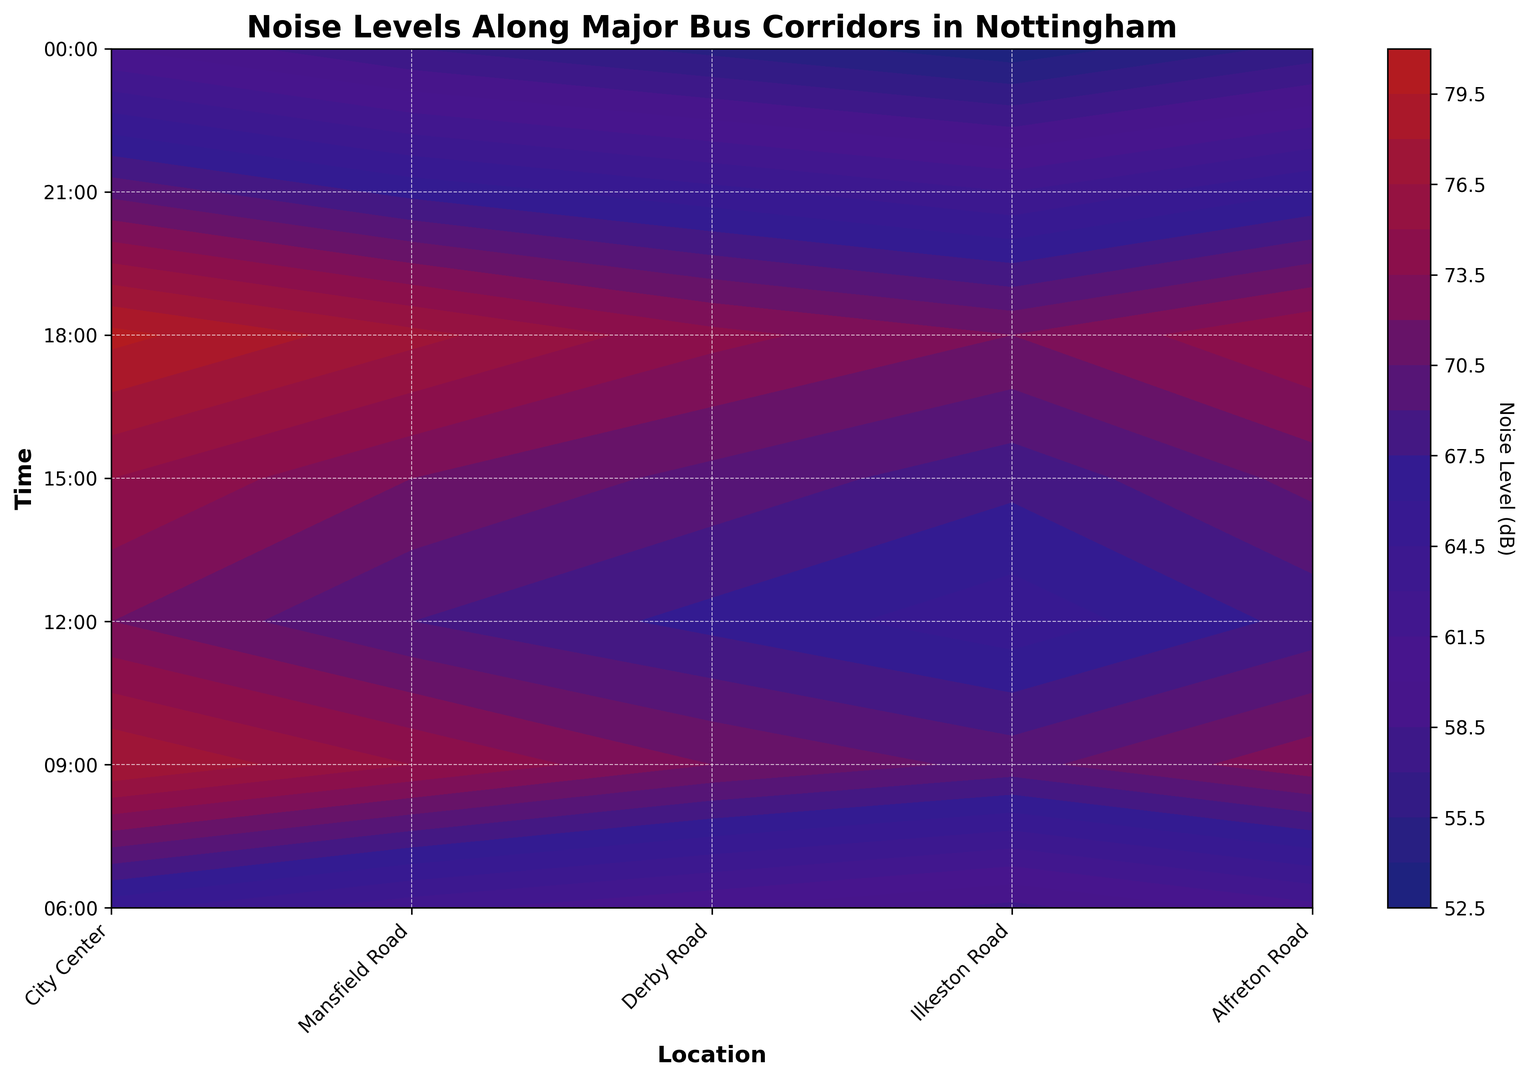Which location has the highest noise level at 18:00? To identify the location with the highest noise level at 18:00, inspect the row corresponding to 18:00. The column "City Center" shows the highest noise level of 80 dB.
Answer: City Center What is the noise level difference between the City Center and Derby Road at 09:00? Locate the noise levels at 09:00 for both locations: City Center is 78 dB and Derby Road is 72 dB. Subtract Derby Road's noise level from the City Center's noise level: 78 - 72 = 6 dB.
Answer: 6 dB Which time of day has the highest overall noise level for Mansfield Road? Scan the column for Mansfield Road and identify the highest value. The highest noise level is 77 dB at 18:00.
Answer: 18:00 On Ilkeston Road, when is the noise level the lowest? Find the row with the lowest noise level in the column for Ilkeston Road. The lowest is at 00:00 with 53 dB.
Answer: 00:00 How does the noise level at 12:00 for Alfreton Road compare to that at 15:00? Compare the noise levels for Alfreton Road at 12:00 and 15:00: 12:00 is 68 dB, and 15:00 is 71 dB. Hence, the noise level at 15:00 is higher.
Answer: Higher at 15:00 What is the average noise level across all locations at 21:00? Add the noise levels for all locations at 21:00: 70 + 67 + 65 + 63 + 66 = 331. Then, divide by the number of locations, which is 5: 331 / 5 = 66.2 dB.
Answer: 66.2 dB During which time interval does City Center experience the largest increase in noise level? Calculate the noise level differences at successive time intervals for City Center: from 06:00 to 09:00 (78 - 65 = 13 dB), from 09:00 to 12:00 (72 - 78 = -6 dB), from 12:00 to 15:00 (75 - 72 = 3 dB), from 15:00 to 18:00 (80 - 75 = 5 dB), and from 18:00 to 21:00 (70 - 80 = -10 dB). The largest increase is from 06:00 to 09:00 with an increase of 13 dB.
Answer: From 06:00 to 09:00 What is the pattern of noise levels from 06:00 to 00:00 for Derby Road? Inspect the values for Derby Road from 06:00 to 00:00: 60, 72, 67, 70, 74, 65, 55. The noise levels initially rise, then fluctuate around 70 dB, decrease slightly at 21:00, and drop significantly at 00:00.
Answer: Rises, fluctuates, then drops How does the color intensity change for City Center from 21:00 to 00:00? Analyze the contour color for City Center from 21:00 to 00:00. The color becomes lighter, indicating a significant decrease in noise level from 70 dB to 60 dB.
Answer: Becomes lighter Which location consistently has lower noise levels throughout the day? Compare noise levels across all times for all locations. Ilkeston Road has consistently lower noise levels (ranging from 53 dB to 72 dB).
Answer: Ilkeston Road 